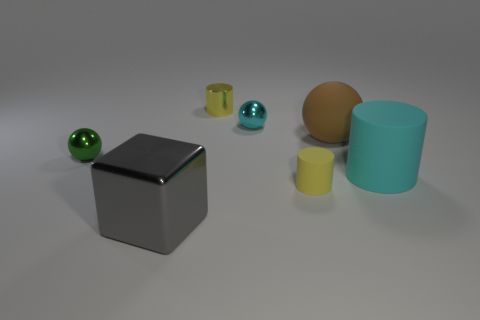What might be the purpose of these objects in this arrangement? This arrangement seems primarily aesthetic, designed to showcase a variety of shapes, textures, and materials. It could be a visual composition created to study the interplay of light and shadow on different surfaces, or perhaps it's for a graphical render to demonstrate rendering techniques or an artist's portfolio to show their ability to create realistic 3D objects. 